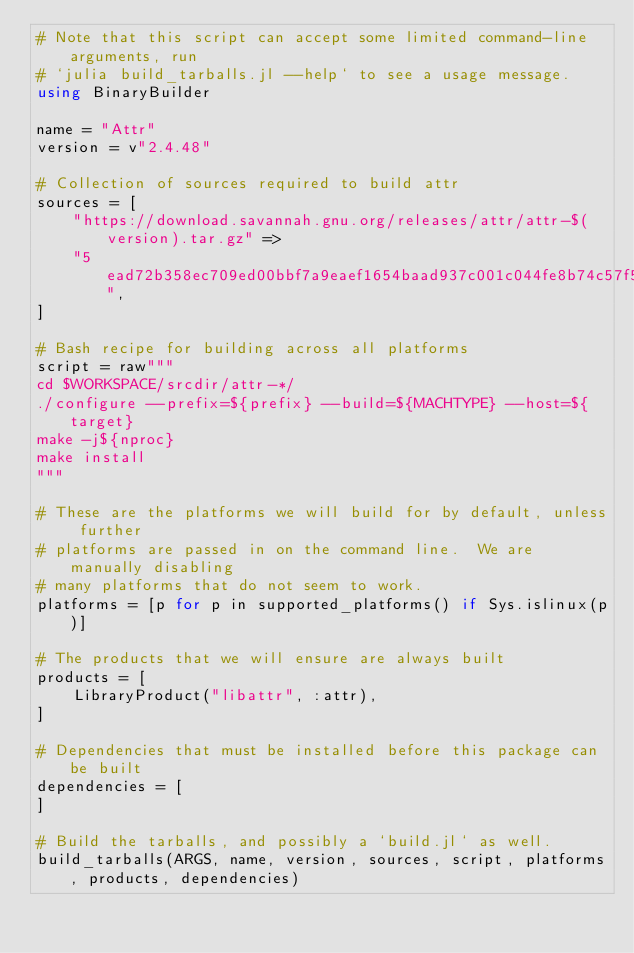Convert code to text. <code><loc_0><loc_0><loc_500><loc_500><_Julia_># Note that this script can accept some limited command-line arguments, run
# `julia build_tarballs.jl --help` to see a usage message.
using BinaryBuilder

name = "Attr"
version = v"2.4.48"

# Collection of sources required to build attr
sources = [
    "https://download.savannah.gnu.org/releases/attr/attr-$(version).tar.gz" =>
    "5ead72b358ec709ed00bbf7a9eaef1654baad937c001c044fe8b74c57f5324e7",
]

# Bash recipe for building across all platforms
script = raw"""
cd $WORKSPACE/srcdir/attr-*/
./configure --prefix=${prefix} --build=${MACHTYPE} --host=${target}
make -j${nproc}
make install
"""

# These are the platforms we will build for by default, unless further
# platforms are passed in on the command line.  We are manually disabling
# many platforms that do not seem to work.
platforms = [p for p in supported_platforms() if Sys.islinux(p)]

# The products that we will ensure are always built
products = [
    LibraryProduct("libattr", :attr),
]

# Dependencies that must be installed before this package can be built
dependencies = [
]

# Build the tarballs, and possibly a `build.jl` as well.
build_tarballs(ARGS, name, version, sources, script, platforms, products, dependencies)
</code> 